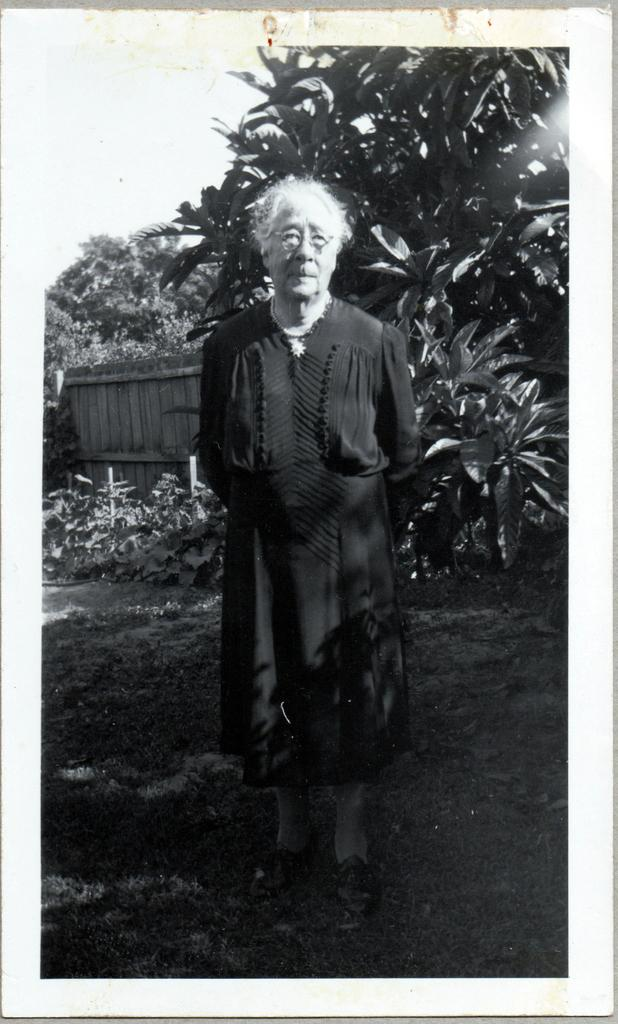What is the main subject in the image? There is a man standing in the image. What type of environment is depicted in the image? There is grass, plants, and trees in the image, suggesting a natural setting. What type of structure is present in the image? There is a wooden wall in the image. What is the color scheme of the image? The image is black and white in color. What type of pet is sleeping on the wooden wall in the image? There is no pet visible in the image, and the man is standing, not sleeping. 